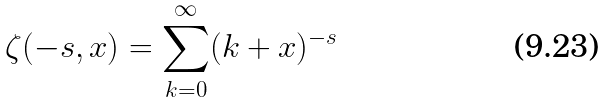Convert formula to latex. <formula><loc_0><loc_0><loc_500><loc_500>\zeta ( - s , x ) = \sum _ { k = 0 } ^ { \infty } ( k + x ) ^ { - s }</formula> 